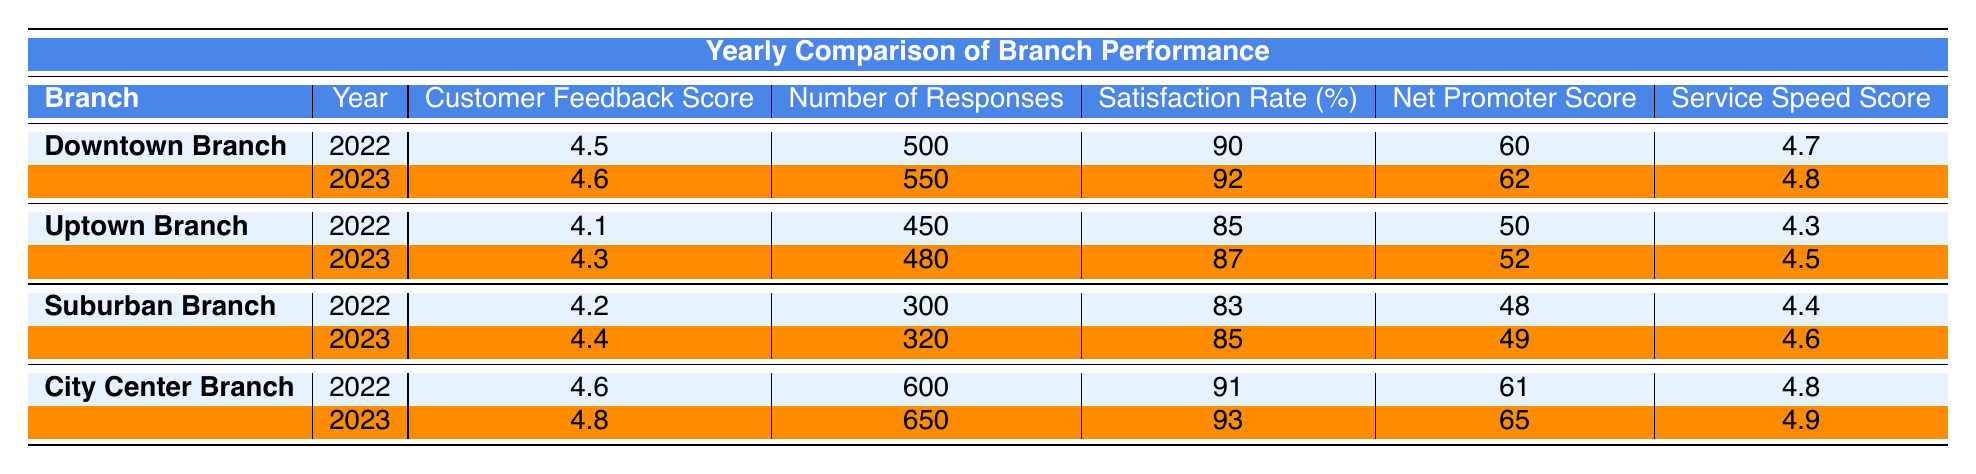What was the customer feedback score for the Downtown Branch in 2022? The table shows that the Downtown Branch had a customer feedback score of 4.5 in the year 2022.
Answer: 4.5 What was the net promoter score for the City Center Branch in 2023? According to the table, the net promoter score for the City Center Branch in 2023 was 65.
Answer: 65 Which branch had the highest satisfaction rate in 2023? By comparing the satisfaction rates for each branch in 2023, the City Center Branch had the highest rate at 93%.
Answer: City Center Branch What is the difference in customer feedback score for the Uptown Branch between 2022 and 2023? The customer feedback score for the Uptown Branch in 2022 is 4.1, and in 2023 it is 4.3. The difference is calculated as 4.3 - 4.1 = 0.2.
Answer: 0.2 Was the service speed score for the Suburban Branch higher in 2023 compared to 2022? In 2022, the service speed score for the Suburban Branch was 4.4, and in 2023 it increased to 4.6. Therefore, the statement is true.
Answer: Yes What was the total number of responses collected for all branches in 2023? The number of responses in 2023 were: Downtown Branch (550), Uptown Branch (480), Suburban Branch (320), and City Center Branch (650). Adding these together gives 550 + 480 + 320 + 650 = 2000.
Answer: 2000 Which branch experienced the least customer feedback score improvement from 2022 to 2023? By comparing the customer feedback scores, the Uptown Branch improved from 4.1 in 2022 to 4.3 in 2023, an increase of 0.2. The Suburban Branch improved from 4.2 to 4.4, also an increase of 0.2. Therefore, both branches experienced the least improvement.
Answer: Uptown Branch and Suburban Branch What percentage increase in satisfaction rate did the Downtown Branch achieve from 2022 to 2023? The satisfaction rate for the Downtown Branch was 90% in 2022 and increased to 92% in 2023. The increase is calculated as (92 - 90) / 90 * 100 = 2.22%.
Answer: 2.22% 